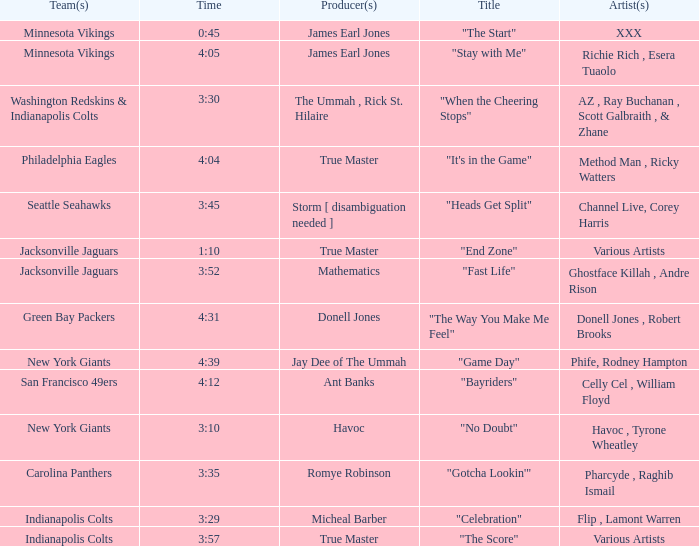Who is the producer of "fast life"? Mathematics. 